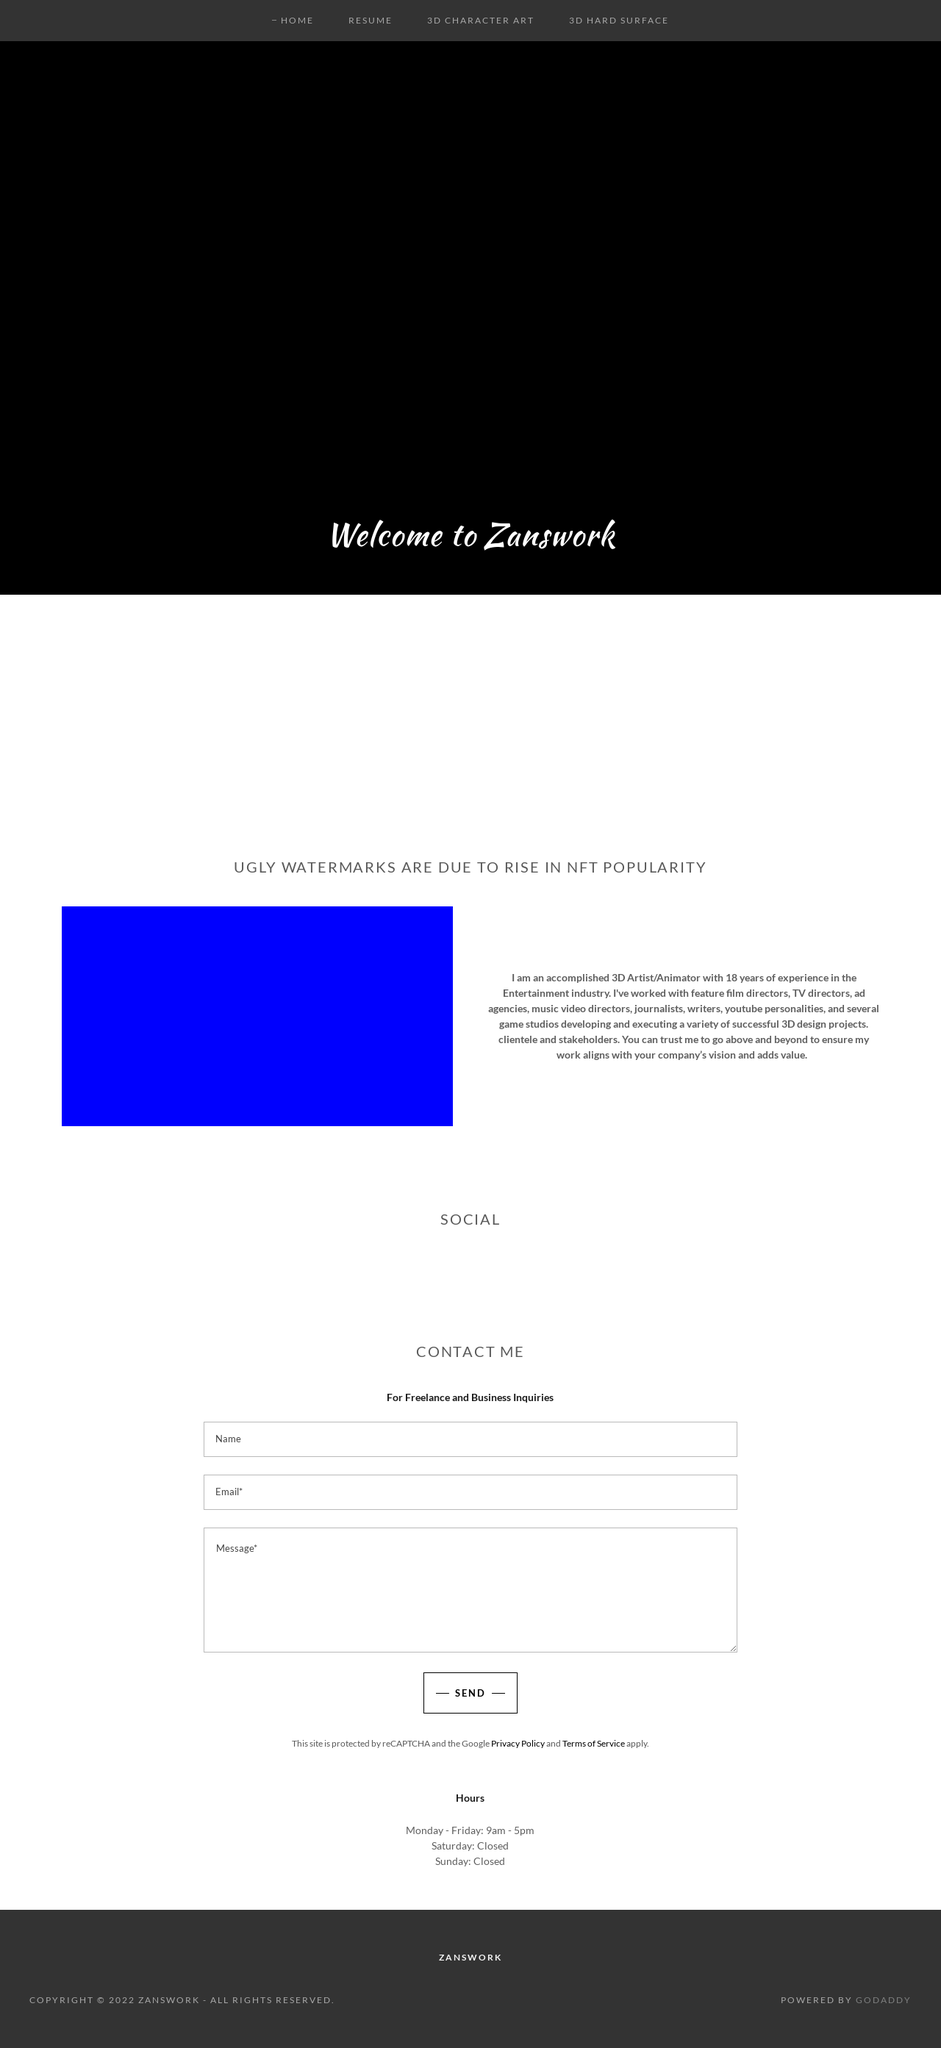What inspired the use of such a strong watermark on the image displayed on your site? The strong watermark seen in the image is likely used as a measure to protect digital artwork, especially with the rising popularity of NFTs (Non-Fungible Tokens). As NFTs increase in popularity, artists are more vigilant about copyright theft, and watermarks are a practical approach to deter unauthorized use or reproduction of their work. This method helps maintain the artist's rights while allowing them to showcase their work publicly. 